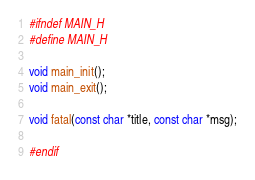<code> <loc_0><loc_0><loc_500><loc_500><_C_>#ifndef MAIN_H
#define MAIN_H

void main_init();
void main_exit();

void fatal(const char *title, const char *msg);

#endif
</code> 